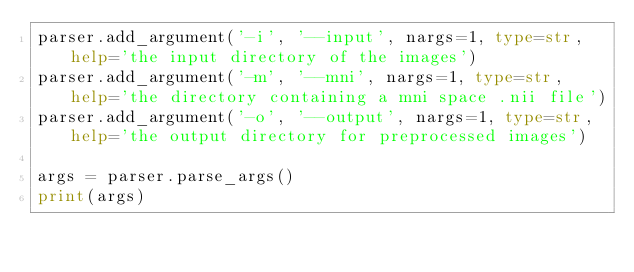<code> <loc_0><loc_0><loc_500><loc_500><_Python_>parser.add_argument('-i', '--input', nargs=1, type=str, help='the input directory of the images')
parser.add_argument('-m', '--mni', nargs=1, type=str, help='the directory containing a mni space .nii file')
parser.add_argument('-o', '--output', nargs=1, type=str, help='the output directory for preprocessed images')

args = parser.parse_args()
print(args)






    </code> 